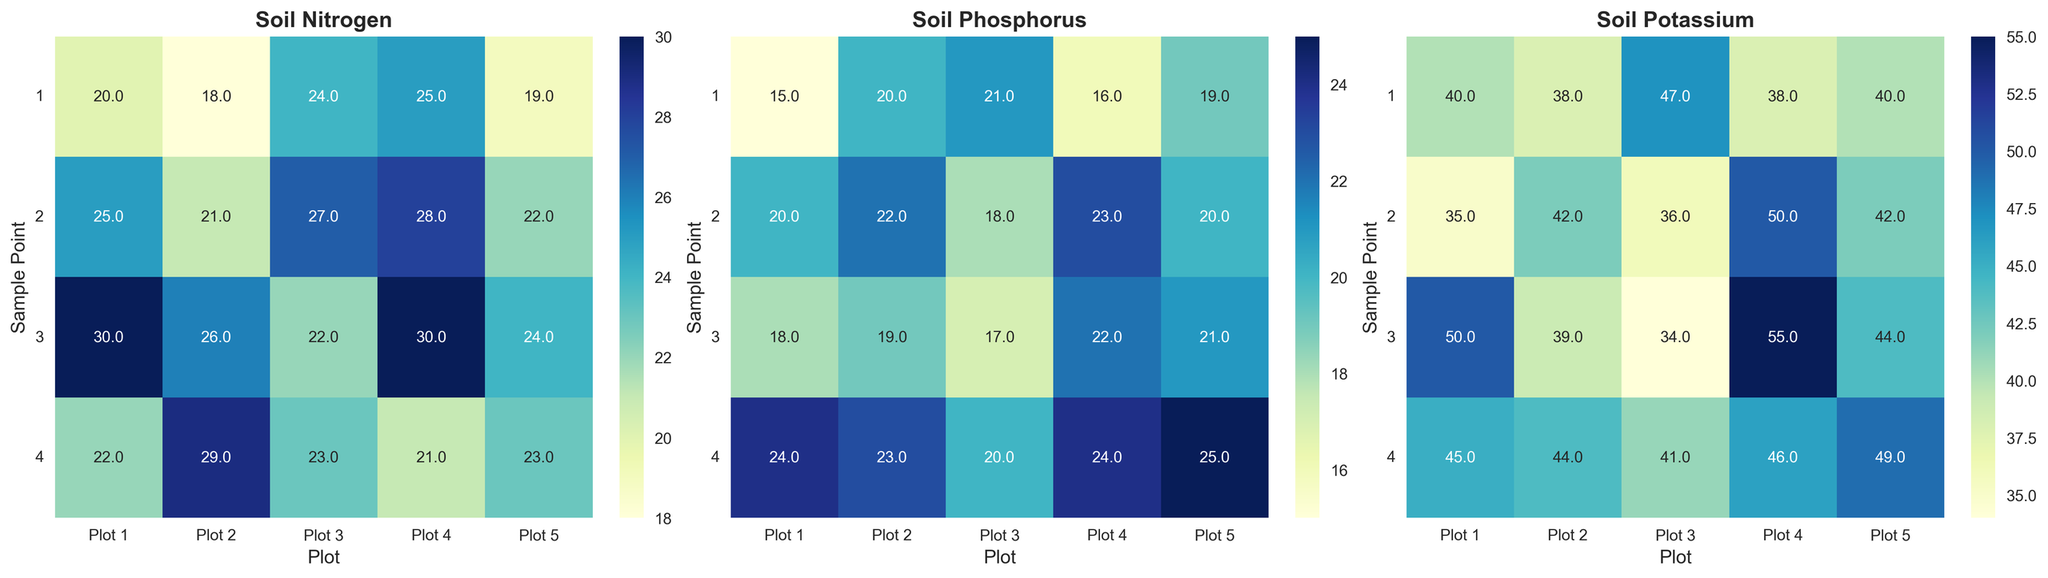What is the nitrogen level at Sample Point 2 in Plot 3? Look at the heatmap for Soil Nitrogen, find the cell corresponding to Sample Point 2 and Plot 3.
Answer: 27 Which plot has the highest phosphorus level and at which sample point? Examine the heatmap for Soil Phosphorus, identify the cell with the darkest shade (or the highest number).
Answer: Plot 4 at Sample Point 4 How does the potassium level vary across Sample Points in Plot 1? Refer to the heatmap for Soil Potassium, observe the varying shades from Sample Points 1 to 4 in Plot 1.
Answer: 40, 35, 50, 45 Compare the nitrogen level in Plot 2 at Sample Point 1 with Plot 4 at Sample Point 1. Which is higher? Look at the heatmap for Soil Nitrogen, find Plot 2 at Sample Point 1 and Plot 4 at Sample Point 1, and compare the values.
Answer: Plot 4 What is the average phosphorus level across all sample points in Plot 5? Sum the phosphorus levels at all sample points in Plot 5 and divide by the number of points. Calculation: (19 + 20 + 21 + 25) / 4
Answer: 21.25 In which plot and at which sample point is the lowest potassium level observed? Navigate through the heatmap for Soil Potassium to find the cell with the lightest shade (or the lowest number).
Answer: Plot 3 at Sample Point 3 What is the median nitrogen level in Plot 1 across different sample points? List the nitrogen values for Plot 1’s sample points, sort them, and find the middle value or the average of the two middle values. Values: 20, 22, 25, 30. Median: (22 + 25) / 2
Answer: 23.5 How does the phosphorus level at Sample Point 4 in Plot 5 compare to Sample Point 2 in Plot 2? Look at the heatmap for Soil Phosphorus, find Sample Point 4 in Plot 5 and Sample Point 2 in Plot 2, and compare the values.
Answer: Plot 5 Sample Point 4 is higher Compare the total sum of nitrogen levels across all sample points in Plot 3 and Plot 4. Which is higher? Sum the nitrogen values for all sample points in Plot 3 and Plot 4 and compare the totals. Plot 3: 24 + 27 + 22 + 23 = 96; Plot 4: 25 + 28 + 30 + 21 = 104
Answer: Plot 4 Which nutrient shows the most consistent levels across Sample Points in Plot 2? Review all three heatmaps, focusing on Plot 2, and determine which nutrient’s cells have the least variation in shading.
Answer: Nitrogen 